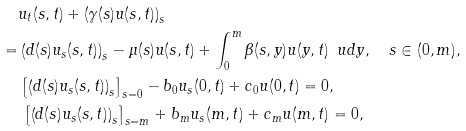<formula> <loc_0><loc_0><loc_500><loc_500>& u _ { t } ( s , t ) + \left ( \gamma ( s ) u ( s , t ) \right ) _ { s } \\ = & \left ( d ( s ) u _ { s } ( s , t ) \right ) _ { s } - \mu ( s ) u ( s , t ) + \int _ { 0 } ^ { m } \beta ( s , y ) u ( y , t ) \, \ u d y , \quad s \in ( 0 , m ) , \\ & \left [ \left ( d ( s ) u _ { s } ( s , t ) \right ) _ { s } \right ] _ { s = 0 } - b _ { 0 } u _ { s } ( 0 , t ) + c _ { 0 } u ( 0 , t ) = 0 , \\ & \, \left [ \left ( d ( s ) u _ { s } ( s , t ) \right ) _ { s } \right ] _ { s = m } + b _ { m } u _ { s } ( m , t ) + c _ { m } u ( m , t ) = 0 ,</formula> 